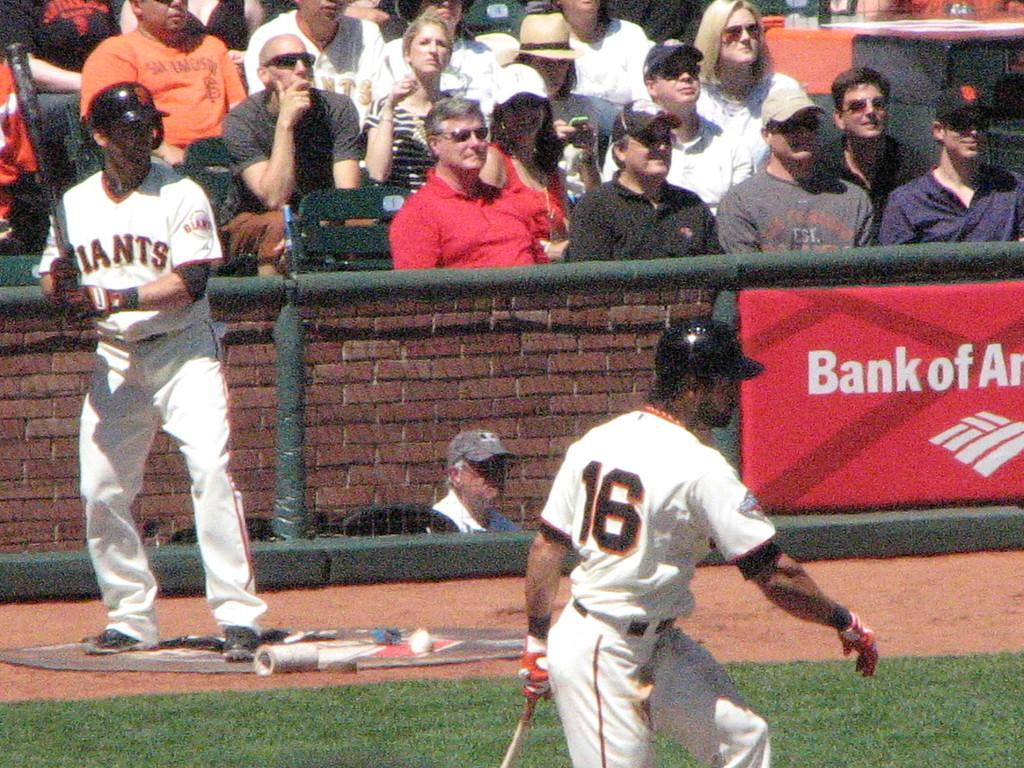<image>
Summarize the visual content of the image. A Giants baseball game is going on with the player 16 in the front and Bank of America banner advertisement present behind them. 